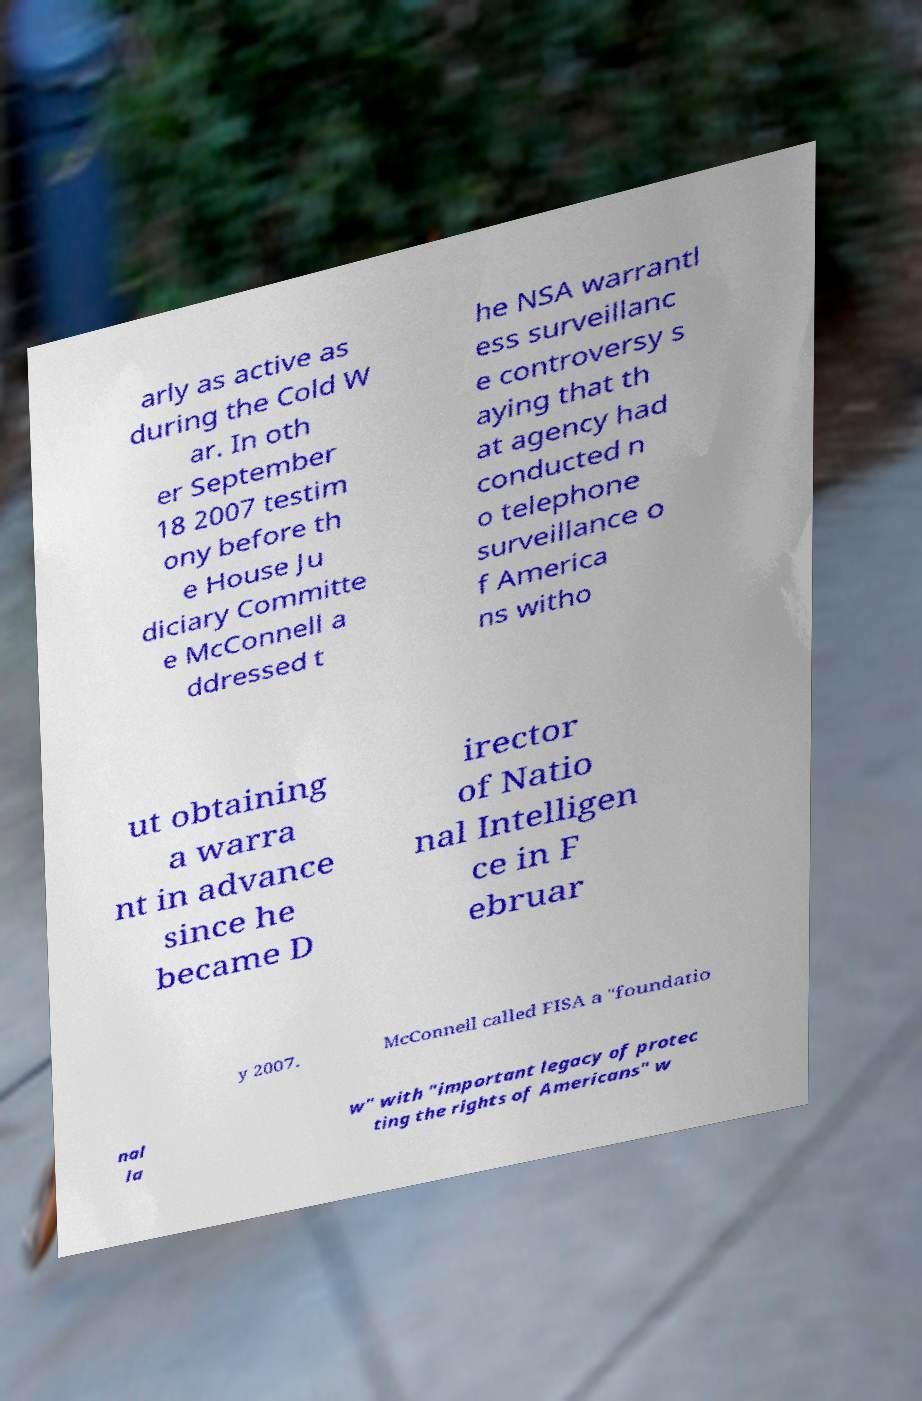For documentation purposes, I need the text within this image transcribed. Could you provide that? arly as active as during the Cold W ar. In oth er September 18 2007 testim ony before th e House Ju diciary Committe e McConnell a ddressed t he NSA warrantl ess surveillanc e controversy s aying that th at agency had conducted n o telephone surveillance o f America ns witho ut obtaining a warra nt in advance since he became D irector of Natio nal Intelligen ce in F ebruar y 2007. McConnell called FISA a "foundatio nal la w" with "important legacy of protec ting the rights of Americans" w 